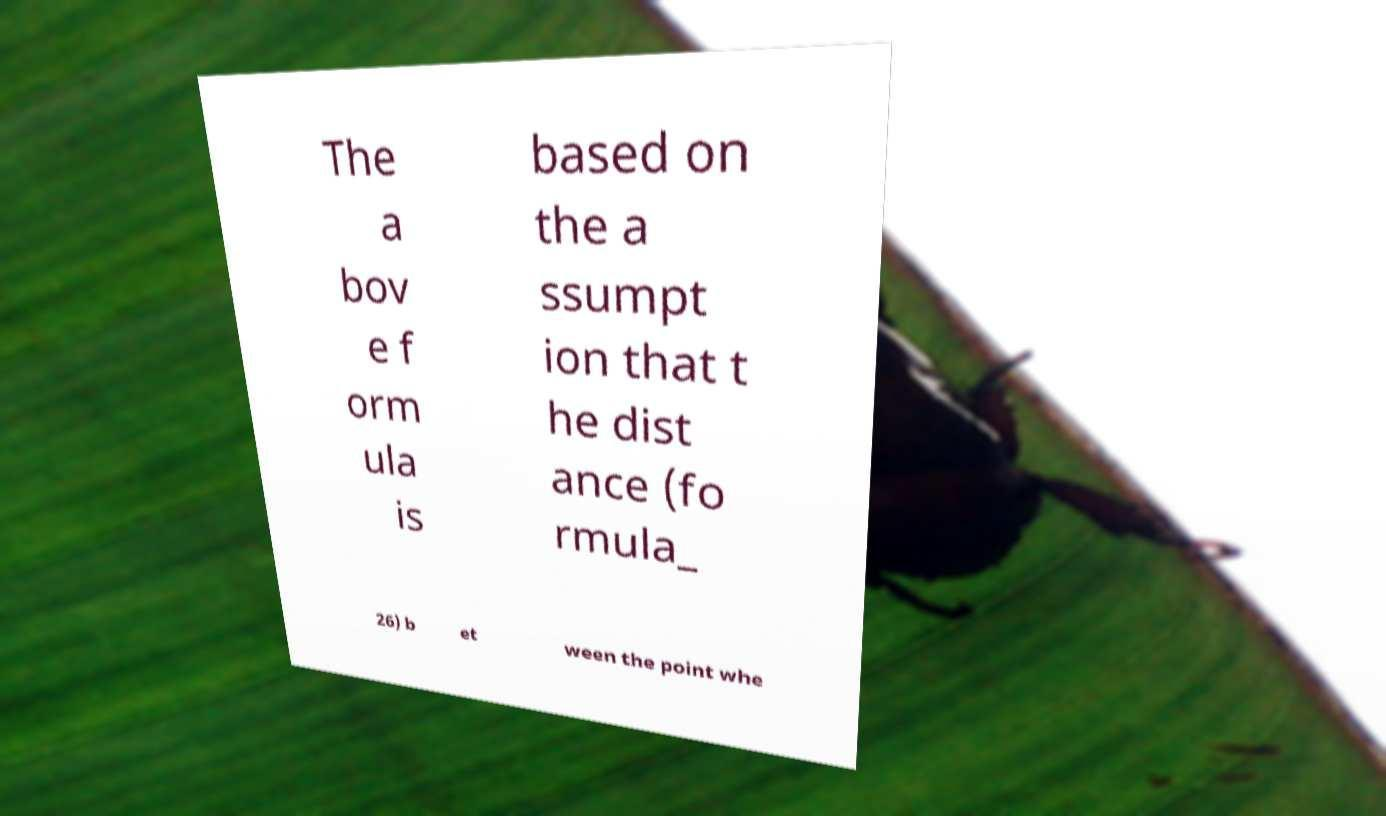Could you extract and type out the text from this image? The a bov e f orm ula is based on the a ssumpt ion that t he dist ance (fo rmula_ 26) b et ween the point whe 